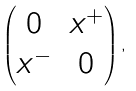<formula> <loc_0><loc_0><loc_500><loc_500>\left ( \begin{matrix} 0 & x ^ { + } \\ x ^ { - } & 0 \end{matrix} \right ) ,</formula> 